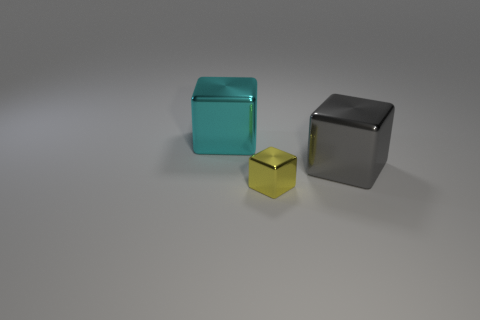Add 3 cyan blocks. How many objects exist? 6 Subtract 0 green blocks. How many objects are left? 3 Subtract all cubes. Subtract all big brown metallic objects. How many objects are left? 0 Add 2 cyan cubes. How many cyan cubes are left? 3 Add 2 small blocks. How many small blocks exist? 3 